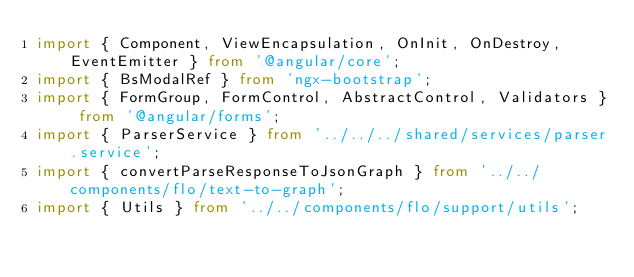<code> <loc_0><loc_0><loc_500><loc_500><_TypeScript_>import { Component, ViewEncapsulation, OnInit, OnDestroy, EventEmitter } from '@angular/core';
import { BsModalRef } from 'ngx-bootstrap';
import { FormGroup, FormControl, AbstractControl, Validators } from '@angular/forms';
import { ParserService } from '../../../shared/services/parser.service';
import { convertParseResponseToJsonGraph } from '../../components/flo/text-to-graph';
import { Utils } from '../../components/flo/support/utils';</code> 